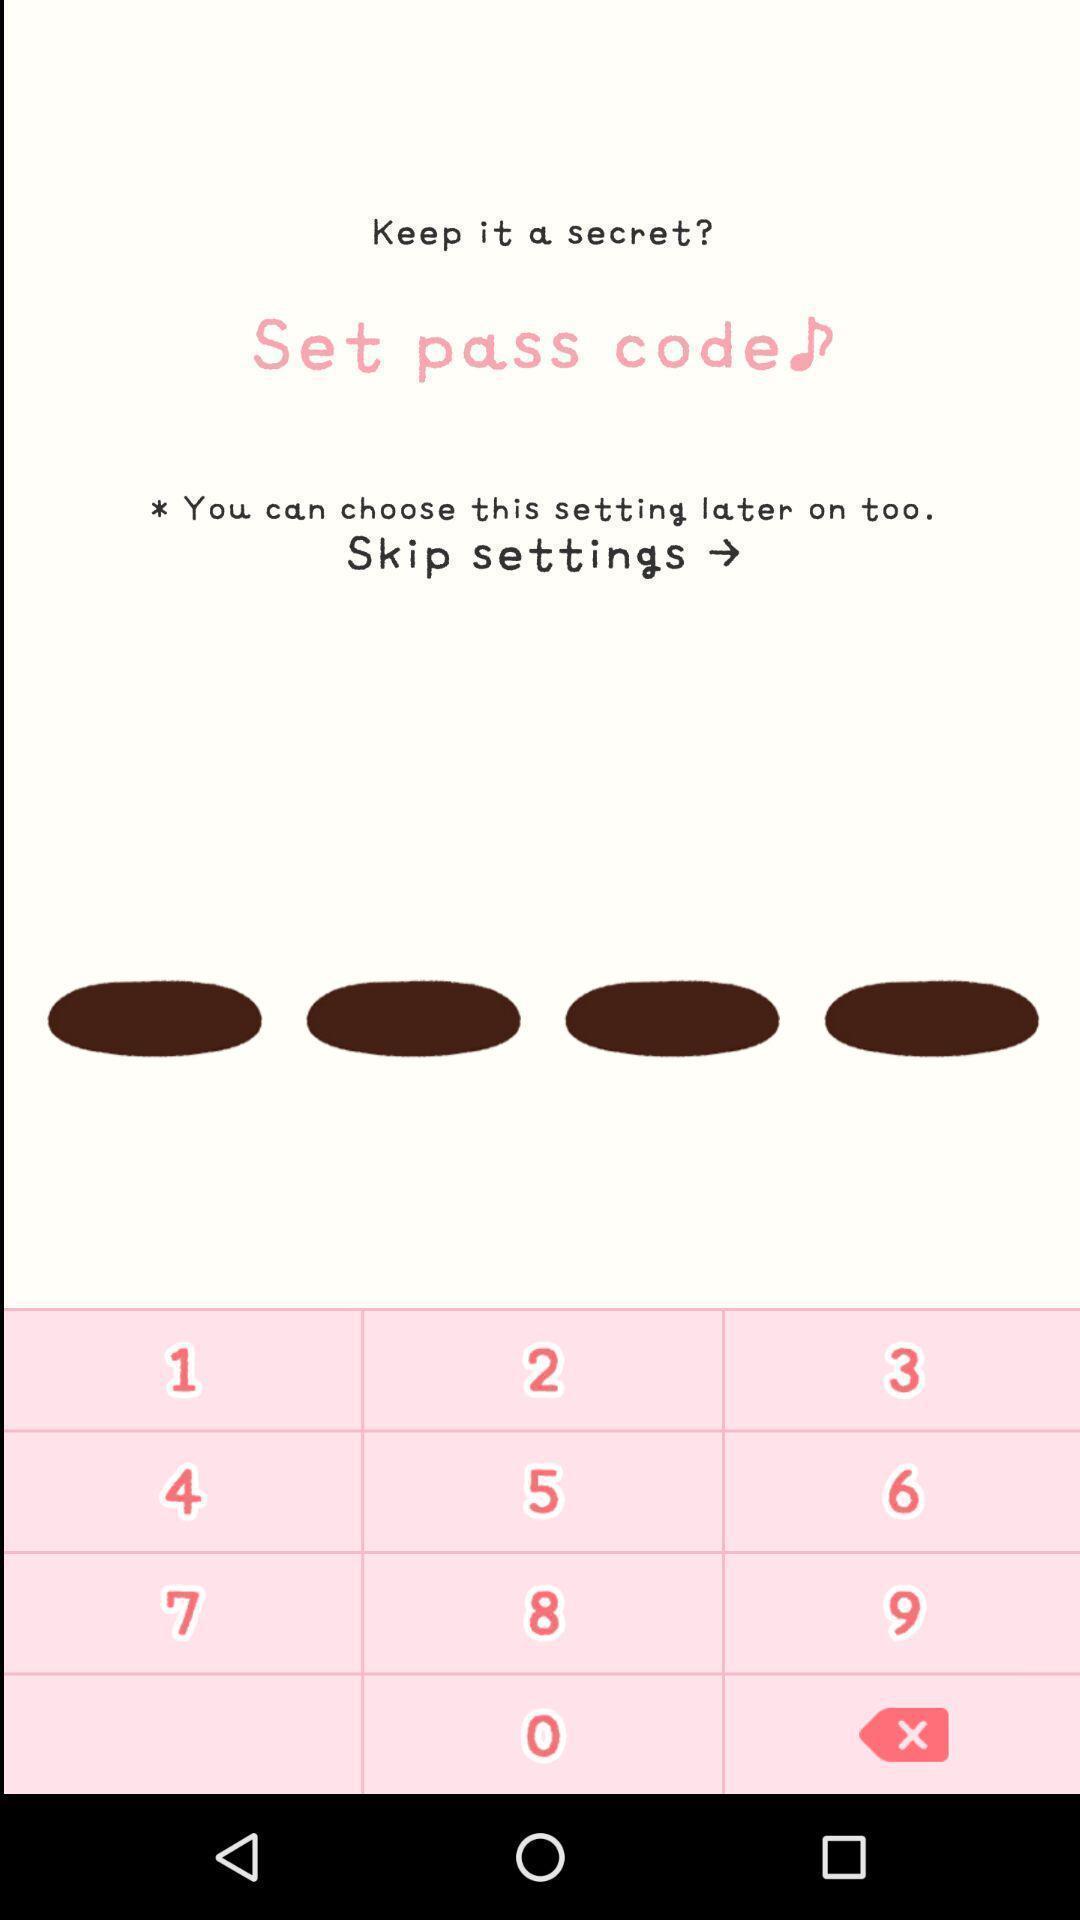Describe the key features of this screenshot. Screen asking to set pass code. 